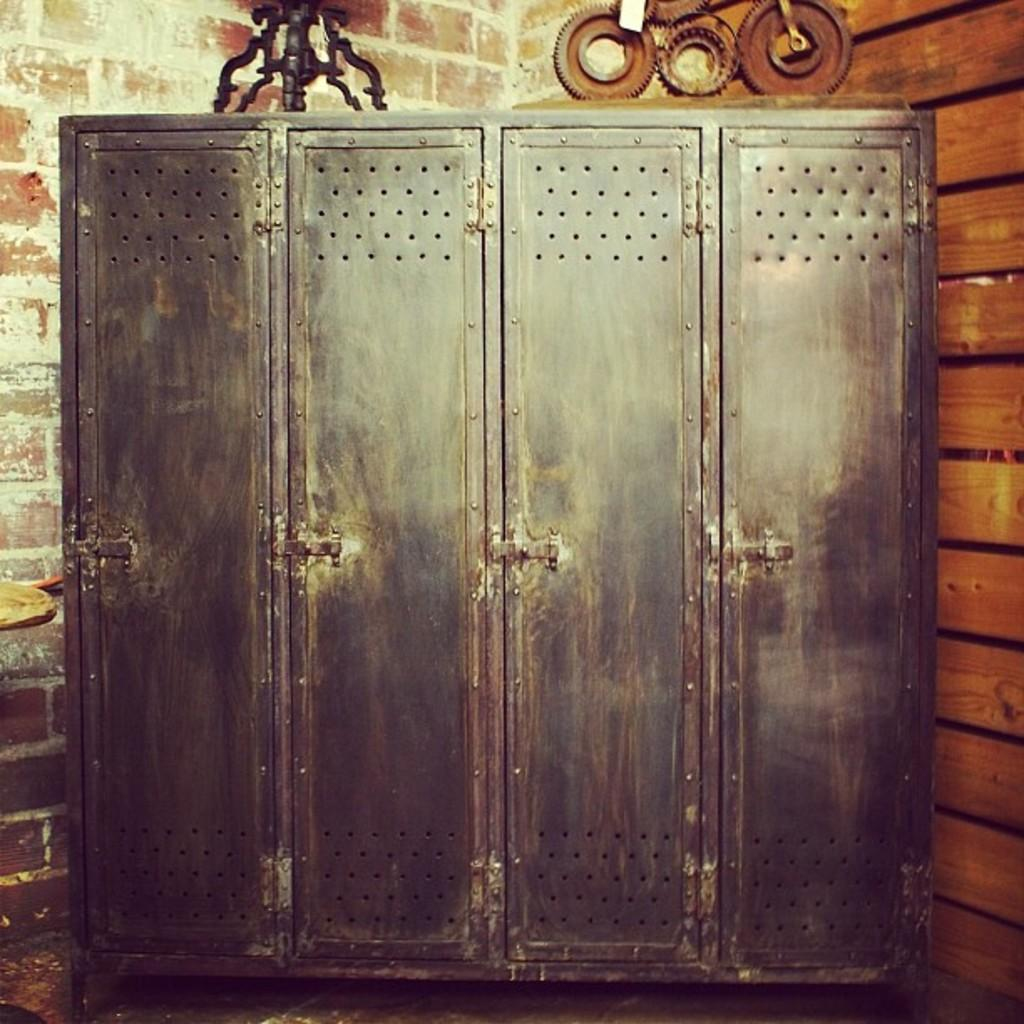What type of furniture is depicted in the image? The image appears to be a cabinet. What can be seen on the left side of the cabinet? There is a brick wall on the left side of the image. What is located on the right side of the cabinet? There is a wooden object on the right side of the image. What type of material is used for the objects at the top of the cabinet? There are iron objects at the top of the image. What type of instrument is being played in the image? There is no instrument present in the image; it depicts a cabinet with surrounding elements. 